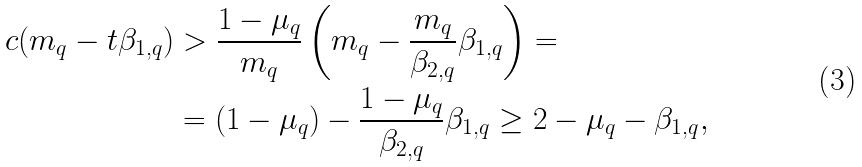Convert formula to latex. <formula><loc_0><loc_0><loc_500><loc_500>c ( m _ { q } - t \beta _ { 1 , q } ) & > \frac { 1 - \mu _ { q } } { m _ { q } } \left ( m _ { q } - \frac { m _ { q } } { \beta _ { 2 , q } } \beta _ { 1 , q } \right ) = \\ & = ( 1 - \mu _ { q } ) - \frac { 1 - \mu _ { q } } { \beta _ { 2 , q } } \beta _ { 1 , q } \geq 2 - \mu _ { q } - \beta _ { 1 , q } ,</formula> 